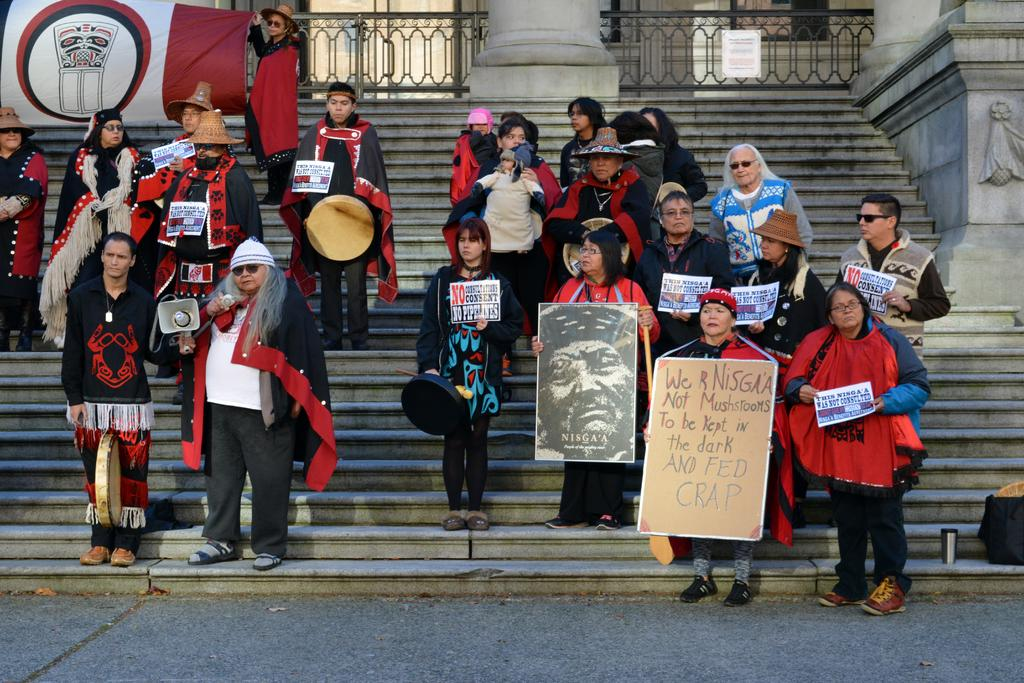What are the persons in the image doing? The persons in the image are standing on steps and holding posters. Is there any additional equipment being used by the persons? Yes, a man is holding a speaker. What can be seen far away in the image? There is a banner far away. Who is holding the banner? A woman is holding the banner. Can you tell me how many toys the queen is holding in the image? There is no queen or toys present in the image. What type of jump is the woman performing while holding the banner? There is no jumping activity depicted in the image; the woman is holding the banner while standing still. 